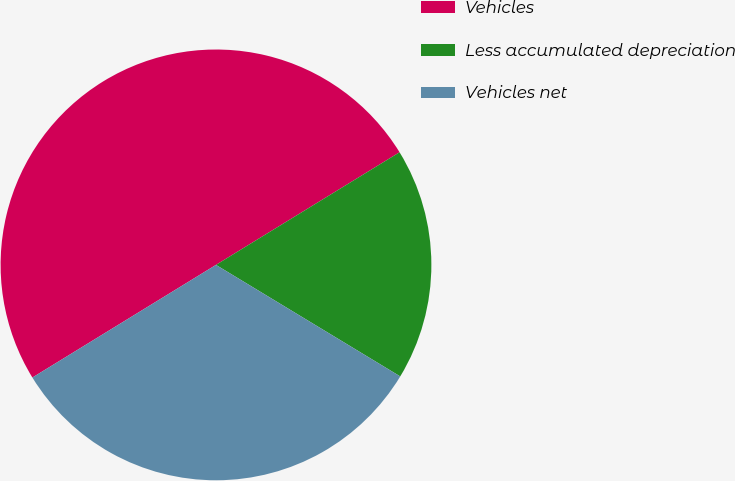Convert chart. <chart><loc_0><loc_0><loc_500><loc_500><pie_chart><fcel>Vehicles<fcel>Less accumulated depreciation<fcel>Vehicles net<nl><fcel>50.0%<fcel>17.42%<fcel>32.58%<nl></chart> 